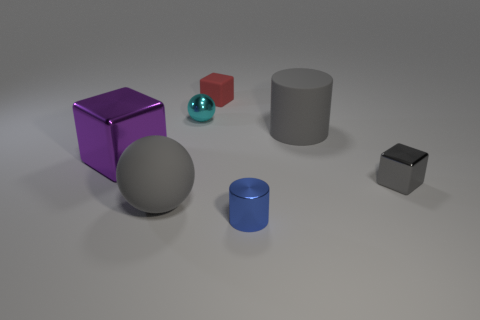Add 3 large purple things. How many objects exist? 10 Subtract all red rubber cubes. How many cubes are left? 2 Subtract all purple cubes. How many cubes are left? 2 Subtract all cyan blocks. How many cyan balls are left? 1 Subtract all big blocks. Subtract all large purple objects. How many objects are left? 5 Add 1 matte things. How many matte things are left? 4 Add 6 tiny gray metal blocks. How many tiny gray metal blocks exist? 7 Subtract 0 brown spheres. How many objects are left? 7 Subtract all blocks. How many objects are left? 4 Subtract 2 cylinders. How many cylinders are left? 0 